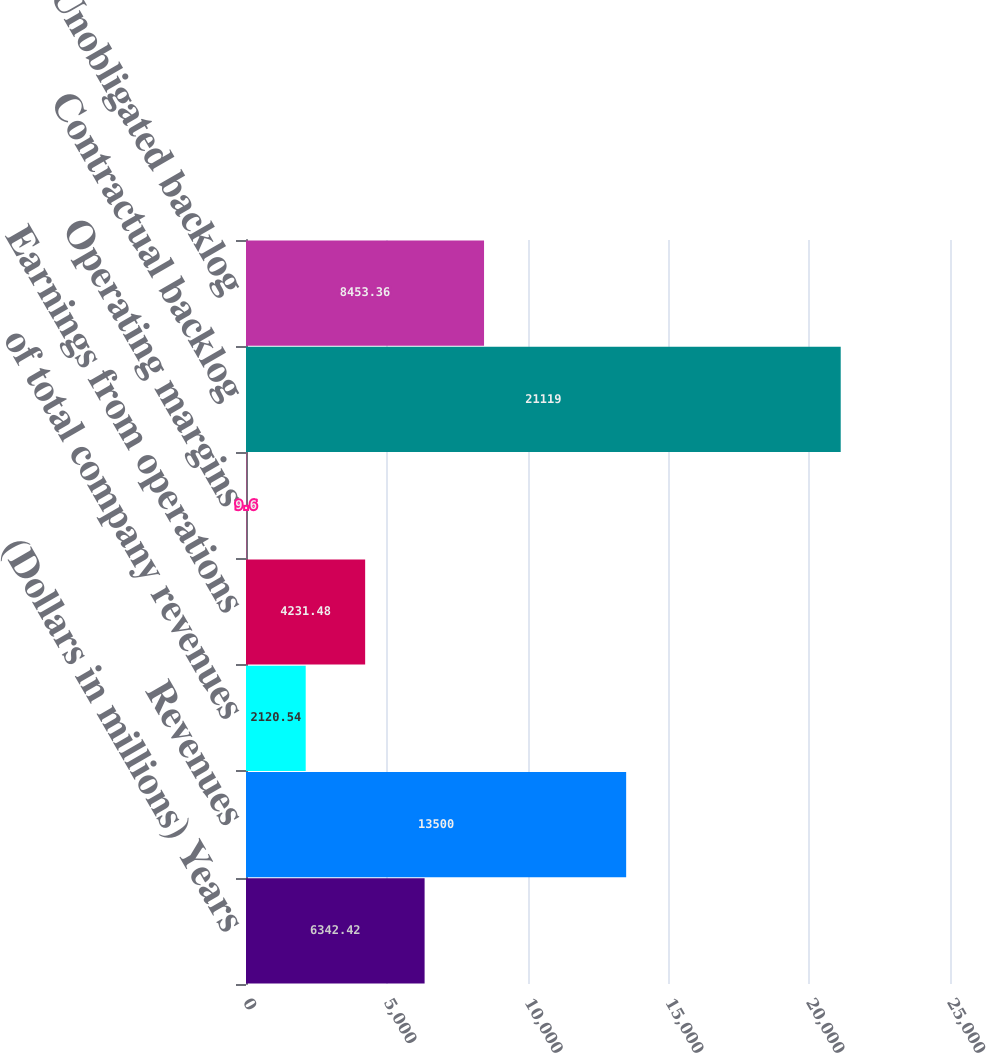Convert chart to OTSL. <chart><loc_0><loc_0><loc_500><loc_500><bar_chart><fcel>(Dollars in millions) Years<fcel>Revenues<fcel>of total company revenues<fcel>Earnings from operations<fcel>Operating margins<fcel>Contractual backlog<fcel>Unobligated backlog<nl><fcel>6342.42<fcel>13500<fcel>2120.54<fcel>4231.48<fcel>9.6<fcel>21119<fcel>8453.36<nl></chart> 